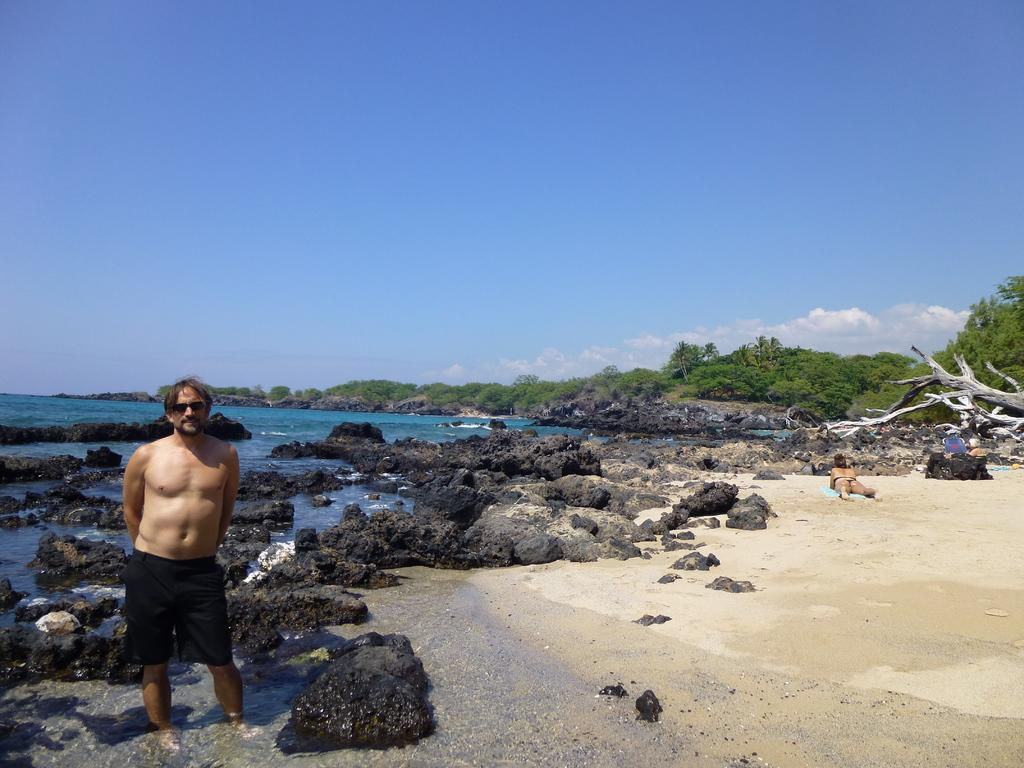What is the man in the image doing? The man is standing in the water. What is happening in the background of the image? There is a person lying on the ground, trees, rocks, water, and the sky visible in the background. Can you describe the natural elements in the background? Trees, rocks, and water are present in the background, along with the sky. What type of lipstick is the man wearing in the image? The man in the image is not wearing lipstick, as there is no indication of makeup or cosmetics. 